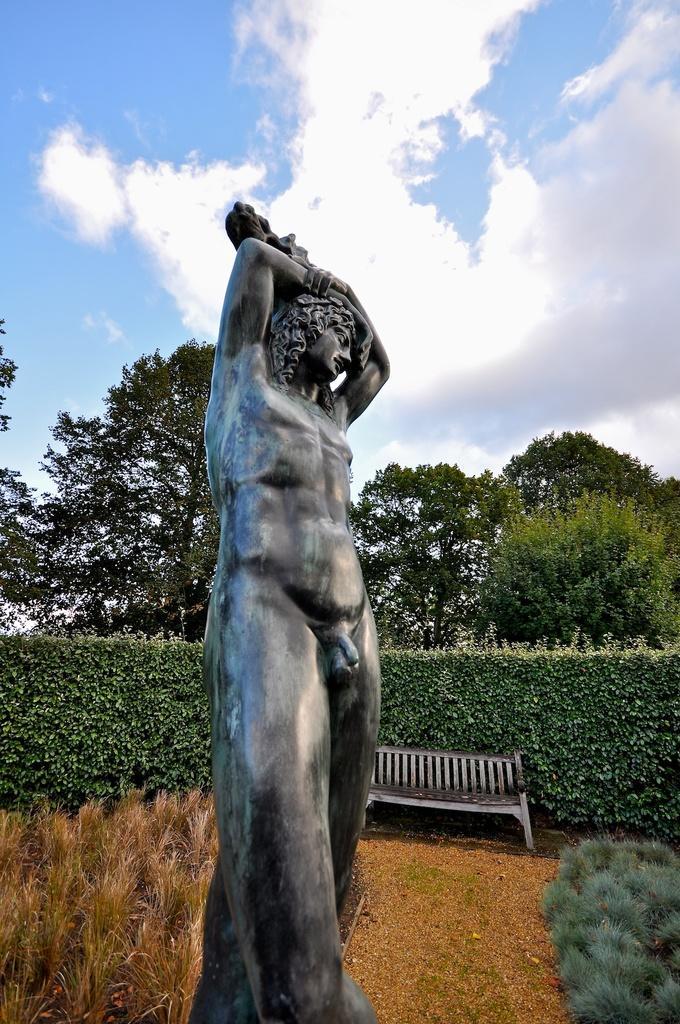In one or two sentences, can you explain what this image depicts? There is a statue. We can see in the background there is a sofa,trees,clouds and sky. 